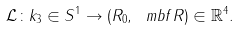<formula> <loc_0><loc_0><loc_500><loc_500>\mathcal { L } \colon k _ { 3 } \in S ^ { 1 } \rightarrow ( R _ { 0 } , \ m b f { R } ) \in \mathbb { R } ^ { 4 } .</formula> 